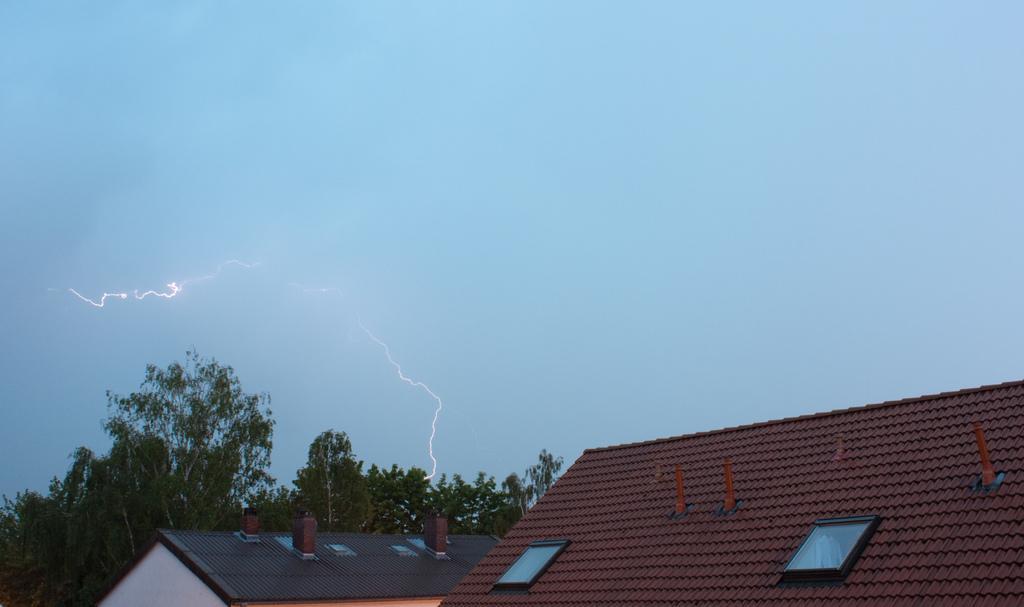Please provide a concise description of this image. There are roofs of 2 buildings. There are trees at the back and thunder in the sky. 